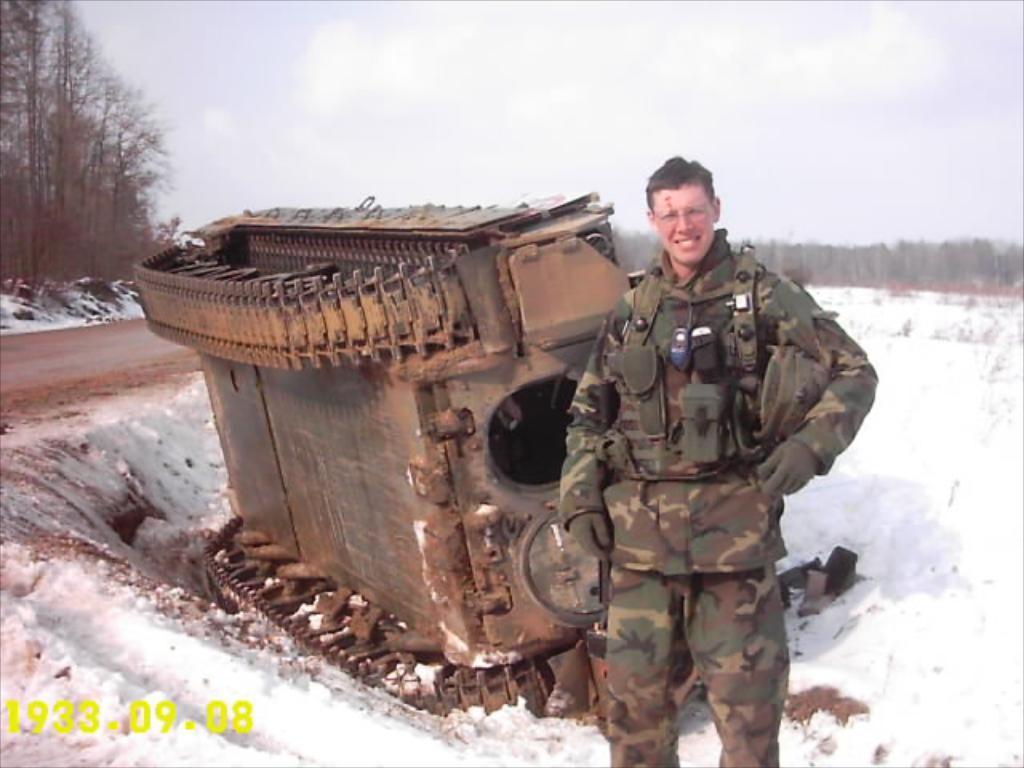Can you describe this image briefly? This image is taken outdoors. At the top of the image there is a sky with clouds. In the background there are many trees. At the bottom of the image there is a ground covered with snow. In the middle of the image a man is standing on the ground and there is a tanker on the ground. 